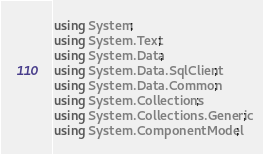<code> <loc_0><loc_0><loc_500><loc_500><_C#_>using System; 
using System.Text; 
using System.Data;
using System.Data.SqlClient;
using System.Data.Common;
using System.Collections;
using System.Collections.Generic;
using System.ComponentModel;</code> 